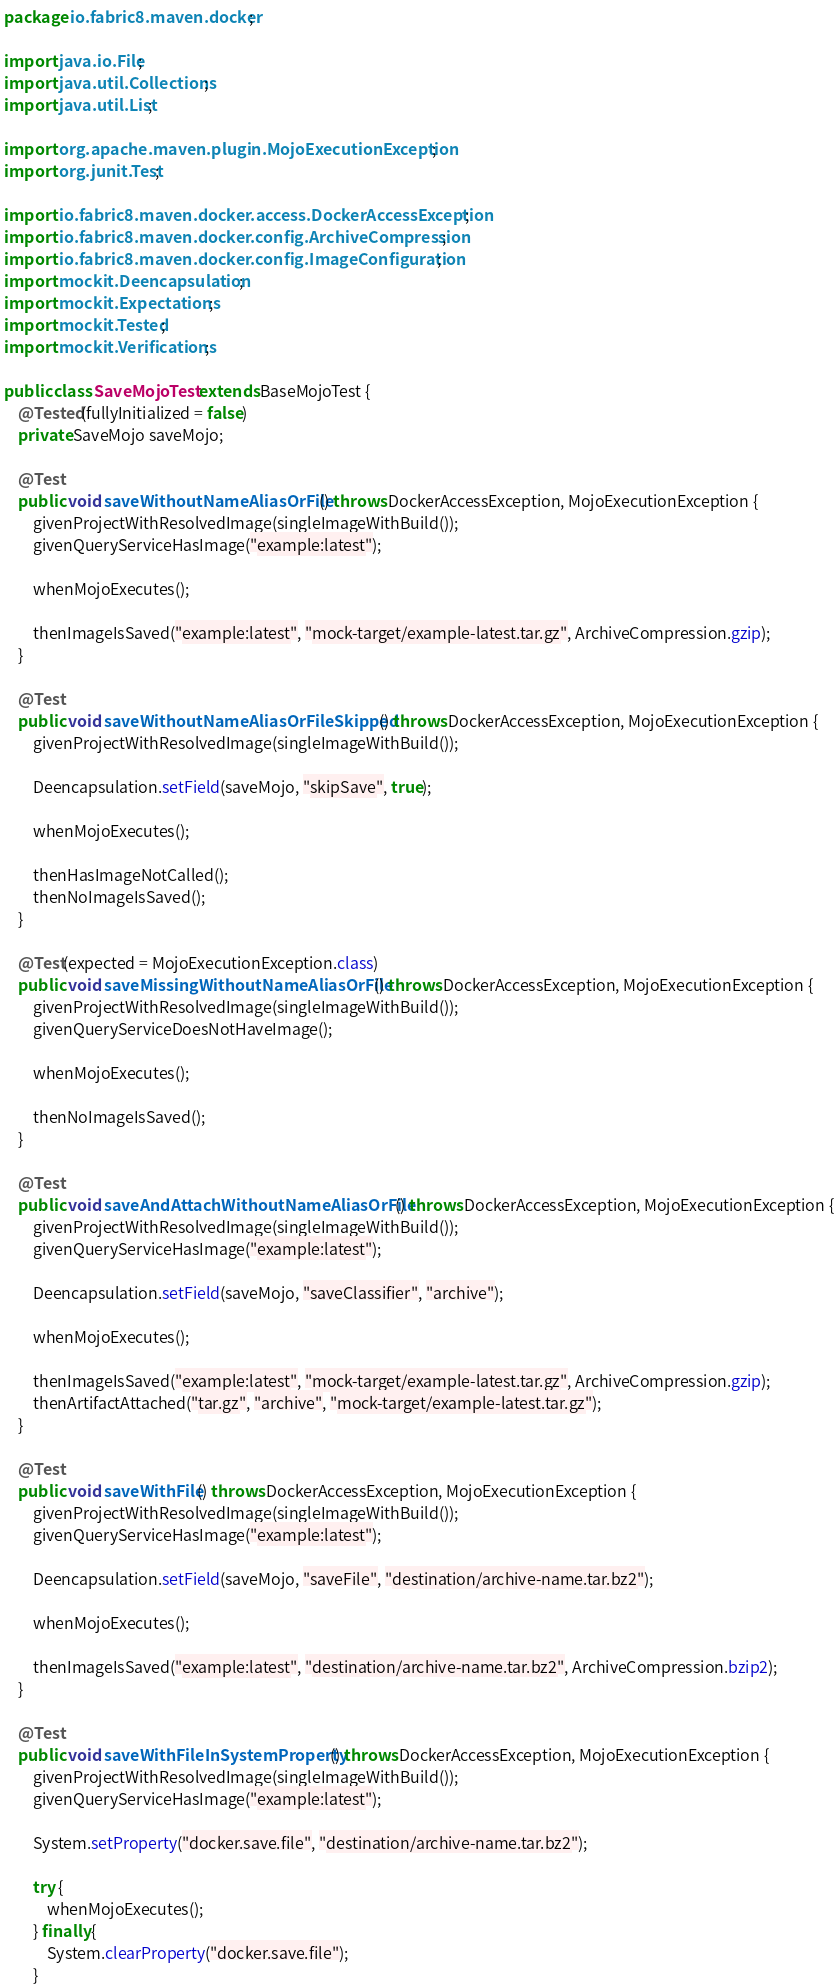<code> <loc_0><loc_0><loc_500><loc_500><_Java_>package io.fabric8.maven.docker;

import java.io.File;
import java.util.Collections;
import java.util.List;

import org.apache.maven.plugin.MojoExecutionException;
import org.junit.Test;

import io.fabric8.maven.docker.access.DockerAccessException;
import io.fabric8.maven.docker.config.ArchiveCompression;
import io.fabric8.maven.docker.config.ImageConfiguration;
import mockit.Deencapsulation;
import mockit.Expectations;
import mockit.Tested;
import mockit.Verifications;

public class SaveMojoTest extends BaseMojoTest {
    @Tested(fullyInitialized = false)
    private SaveMojo saveMojo;

    @Test
    public void saveWithoutNameAliasOrFile() throws DockerAccessException, MojoExecutionException {
        givenProjectWithResolvedImage(singleImageWithBuild());
        givenQueryServiceHasImage("example:latest");

        whenMojoExecutes();

        thenImageIsSaved("example:latest", "mock-target/example-latest.tar.gz", ArchiveCompression.gzip);
    }

    @Test
    public void saveWithoutNameAliasOrFileSkipped() throws DockerAccessException, MojoExecutionException {
        givenProjectWithResolvedImage(singleImageWithBuild());

        Deencapsulation.setField(saveMojo, "skipSave", true);

        whenMojoExecutes();

        thenHasImageNotCalled();
        thenNoImageIsSaved();
    }

    @Test(expected = MojoExecutionException.class)
    public void saveMissingWithoutNameAliasOrFile() throws DockerAccessException, MojoExecutionException {
        givenProjectWithResolvedImage(singleImageWithBuild());
        givenQueryServiceDoesNotHaveImage();

        whenMojoExecutes();

        thenNoImageIsSaved();
    }

    @Test
    public void saveAndAttachWithoutNameAliasOrFile() throws DockerAccessException, MojoExecutionException {
        givenProjectWithResolvedImage(singleImageWithBuild());
        givenQueryServiceHasImage("example:latest");

        Deencapsulation.setField(saveMojo, "saveClassifier", "archive");

        whenMojoExecutes();

        thenImageIsSaved("example:latest", "mock-target/example-latest.tar.gz", ArchiveCompression.gzip);
        thenArtifactAttached("tar.gz", "archive", "mock-target/example-latest.tar.gz");
    }

    @Test
    public void saveWithFile() throws DockerAccessException, MojoExecutionException {
        givenProjectWithResolvedImage(singleImageWithBuild());
        givenQueryServiceHasImage("example:latest");

        Deencapsulation.setField(saveMojo, "saveFile", "destination/archive-name.tar.bz2");

        whenMojoExecutes();

        thenImageIsSaved("example:latest", "destination/archive-name.tar.bz2", ArchiveCompression.bzip2);
    }

    @Test
    public void saveWithFileInSystemProperty() throws DockerAccessException, MojoExecutionException {
        givenProjectWithResolvedImage(singleImageWithBuild());
        givenQueryServiceHasImage("example:latest");

        System.setProperty("docker.save.file", "destination/archive-name.tar.bz2");

        try {
            whenMojoExecutes();
        } finally {
            System.clearProperty("docker.save.file");
        }
</code> 